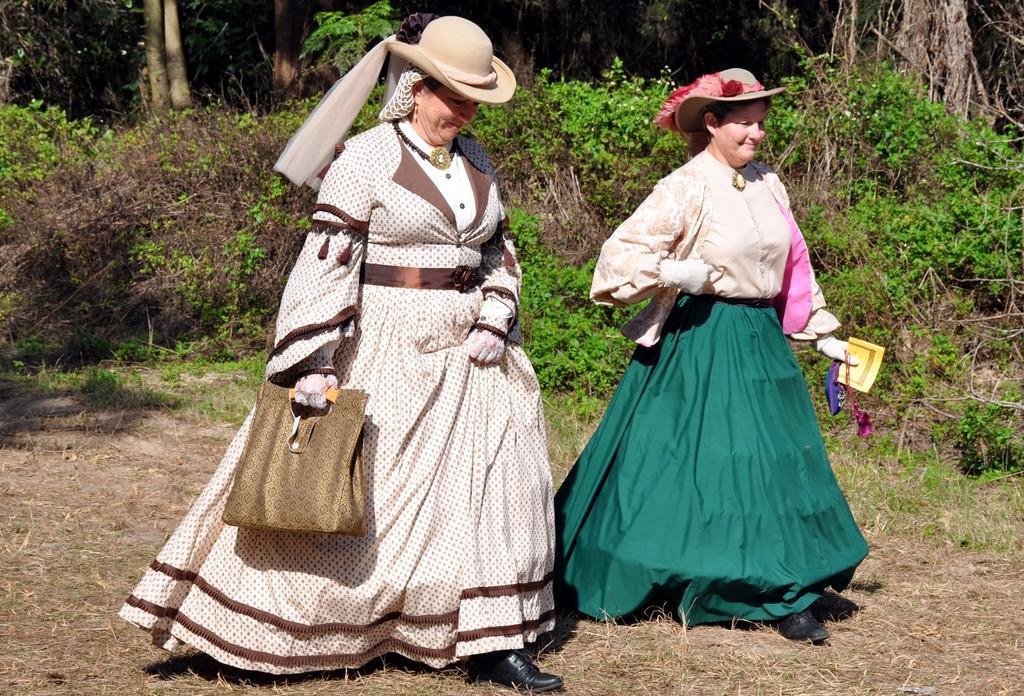How would you summarize this image in a sentence or two? In this image there are two persons with hats are walking, and in the background there are plants. 